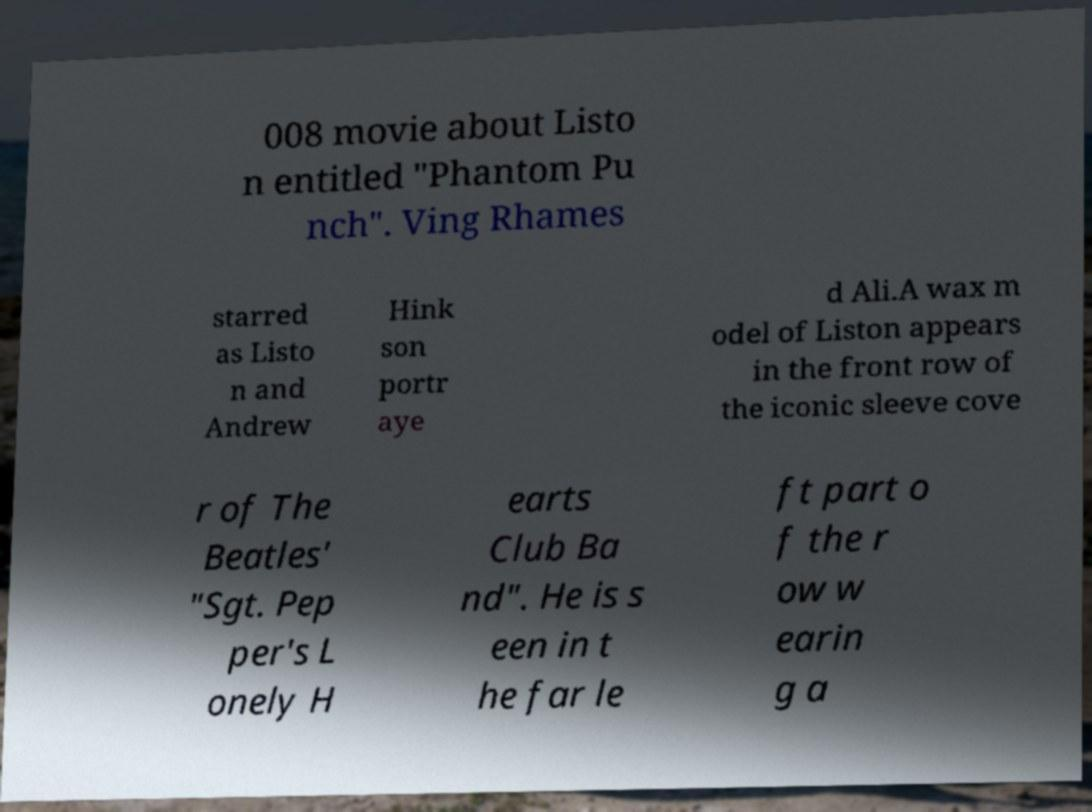There's text embedded in this image that I need extracted. Can you transcribe it verbatim? 008 movie about Listo n entitled "Phantom Pu nch". Ving Rhames starred as Listo n and Andrew Hink son portr aye d Ali.A wax m odel of Liston appears in the front row of the iconic sleeve cove r of The Beatles' "Sgt. Pep per's L onely H earts Club Ba nd". He is s een in t he far le ft part o f the r ow w earin g a 